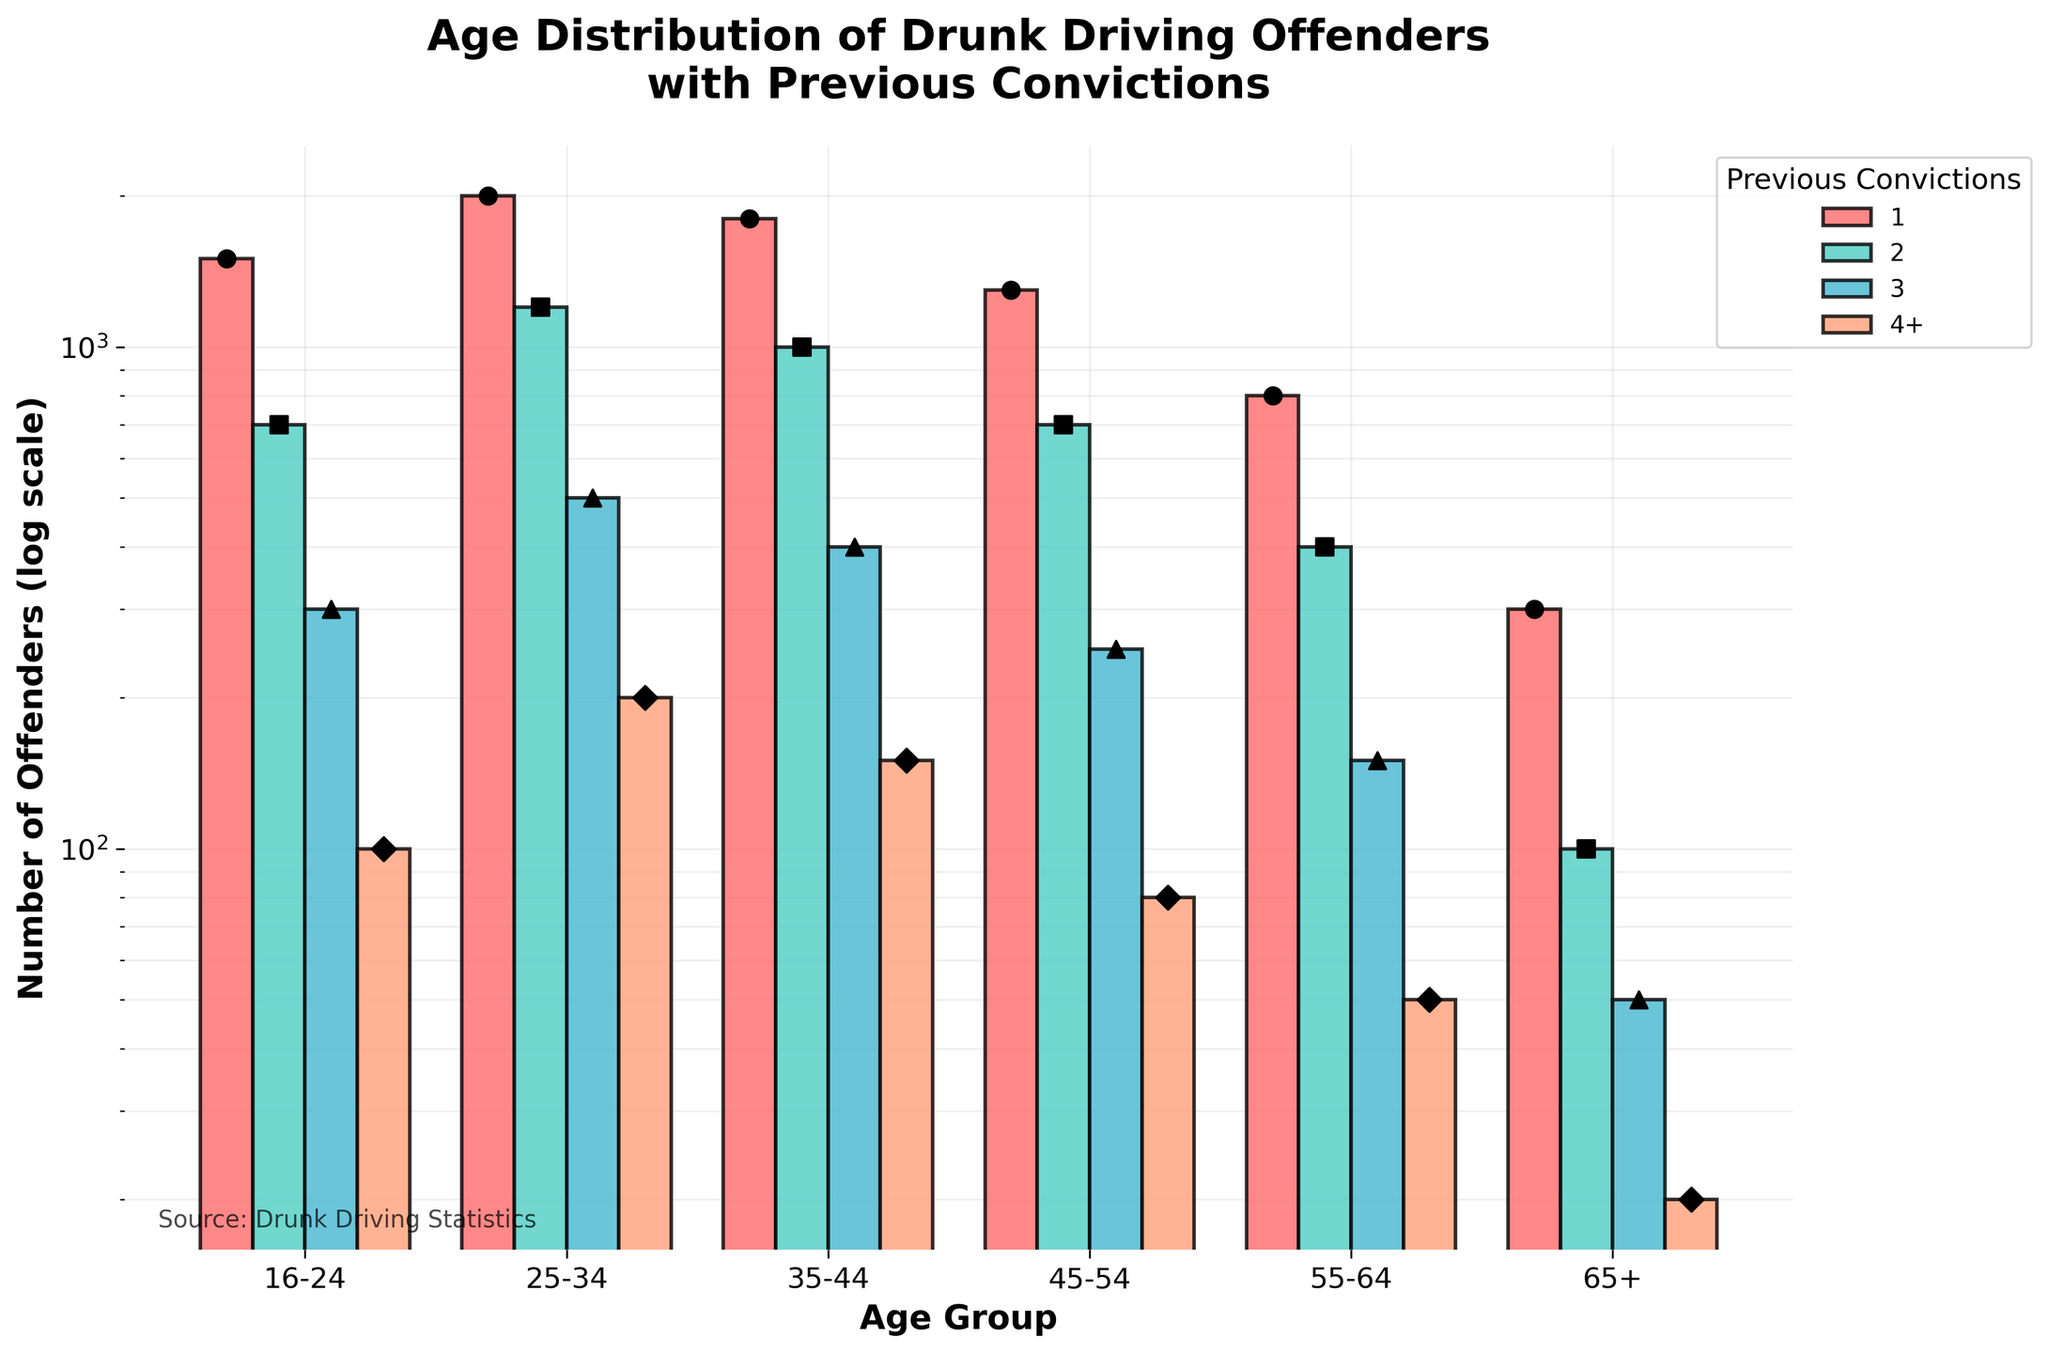What's the title of the figure? The title of the figure is located at the top and is generally in a larger, bold font to stand out.
Answer: Age Distribution of Drunk Driving Offenders with Previous Convictions What is the y-axis representing? The y-axis represents the number of offenders and is labeled "Number of Offenders (log scale)" showing that it uses a log scale for representation.
Answer: Number of offenders (log scale) How does the number of offenders with 1 previous conviction compare among different age groups? To answer this, we observe the heights of the bars for each age group corresponding to "1 previous conviction". The tallest bar for "1 previous conviction" is for the 25-34 age group, then 35-44, followed by 16-24, 45-54, 55-64, and finally 65+.
Answer: 25-34 has the highest, followed by 35-44, 16-24, 45-54, 55-64, and 65+ Which age group has the lowest number of offenders with 4+ previous convictions? We look for the shortest bar corresponding to "4+ previous convictions" across all age groups. The age group 65+ has the lowest number of offenders with 4+ previous convictions.
Answer: 65+ Approximately how many offenders aged 16-24 have 2 previous convictions compared to those aged 55-64 with 2 previous convictions? To answer this, we check the heights of the bars for "2 previous convictions" within the age groups 16-24 and 55-64. The count for 16-24 is 700 while for 55-64, it is 400.
Answer: 16-24 have 700, 55-64 have 400 What is the trend of offenders with increasing age for those with 1 previous conviction? Observing the bars for "1 previous conviction", there is a general decline in the number of offenders as the age increases from 16-24 to 65+.
Answer: Decreasing trend Which age group has the highest number of offenders with 3 previous convictions? We locate the tallest bar corresponding to "3 previous convictions" across all age groups. The 25-34 age group has the highest number of offenders with 3 previous convictions.
Answer: 25-34 Compare the number of offenders with 4+ previous convictions between the age groups 45-54 and 55-64. For "4+ previous convictions", the bar for age group 45-54 is higher at 80 while for 55-64 it is 50.
Answer: 45-54 has more than 55-64 What is the pattern observed in the number of offenders with 2 previous convictions across different age groups? We see the bars representing "2 previous convictions" and notice the highest number is in the 25-34 age group, followed by 35-44, 16-24, 45-54, 55-64, and 65+.
Answer: Peaks at 25-34 and typically decreases with age If combined, how many offenders aged 16-24 have 1, 2, and 3 previous convictions? Adding up the counts for the 16-24 age group for "1 previous conviction", "2 previous convictions", and "3 previous convictions" gives us 1500 + 700 + 300 = 2500 offenders.
Answer: 2500 